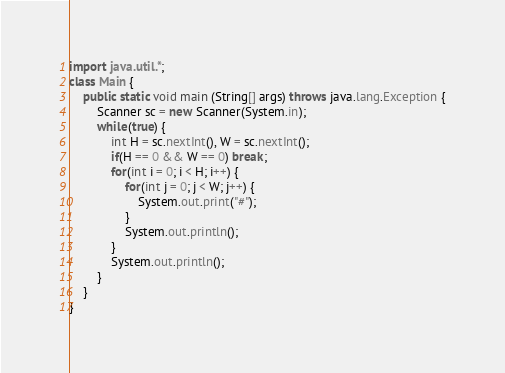Convert code to text. <code><loc_0><loc_0><loc_500><loc_500><_Java_>import java.util.*;
class Main {
	public static void main (String[] args) throws java.lang.Exception {
		Scanner sc = new Scanner(System.in);
		while(true) {
			int H = sc.nextInt(), W = sc.nextInt();
			if(H == 0 && W == 0) break;
			for(int i = 0; i < H; i++) {
				for(int j = 0; j < W; j++) {
					System.out.print("#");
				}
				System.out.println();
			}
			System.out.println();
		}
	}
}</code> 